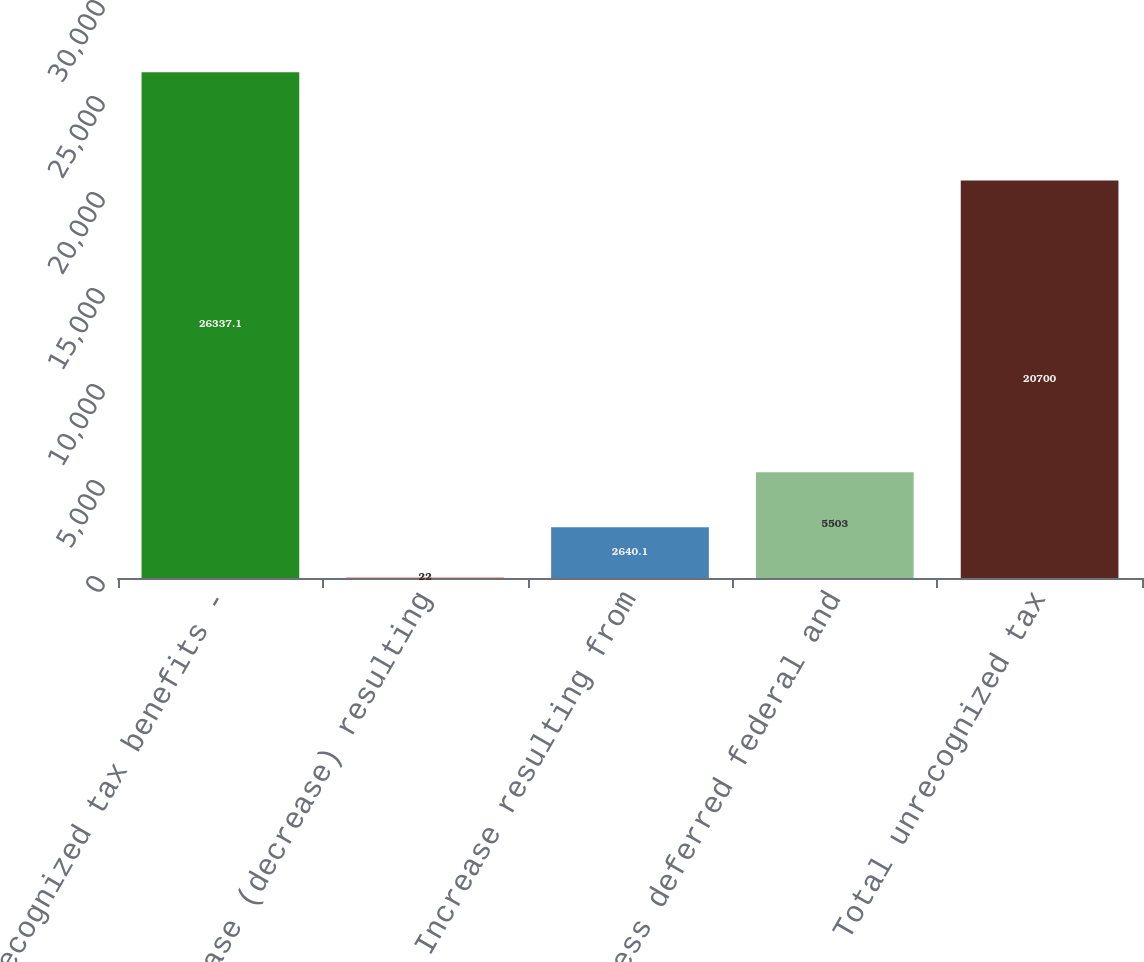Convert chart to OTSL. <chart><loc_0><loc_0><loc_500><loc_500><bar_chart><fcel>Unrecognized tax benefits -<fcel>Increase (decrease) resulting<fcel>Increase resulting from<fcel>Less deferred federal and<fcel>Total unrecognized tax<nl><fcel>26337.1<fcel>22<fcel>2640.1<fcel>5503<fcel>20700<nl></chart> 